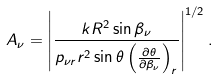<formula> <loc_0><loc_0><loc_500><loc_500>A _ { \nu } = \left | \frac { k R ^ { 2 } \sin \beta _ { \nu } } { p _ { \nu { r } } r ^ { 2 } \sin \theta \left ( \frac { \partial \theta } { \partial \beta _ { \nu } } \right ) _ { r } } \right | ^ { 1 / 2 } .</formula> 